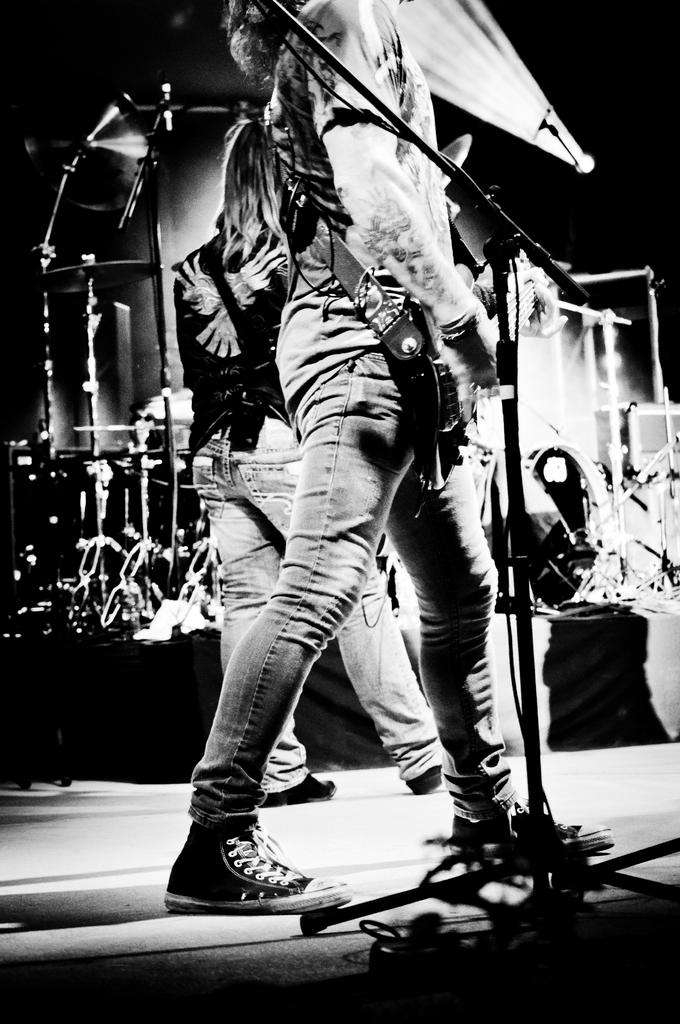How many people are in the image? There are two people in the image. What are the people wearing? The people are wearing dresses. What object is in front of one of the people? There is a microphone in front of one of the people. What can be seen in the background of the image? There are musical instruments in the background. What is the color scheme of the image? The image is black and white. What type of science experiment is being conducted by the people in the image? There is no science experiment present in the image; it features two people, a microphone, and musical instruments. Can you see a yoke in the image? There is no yoke present in the image. 